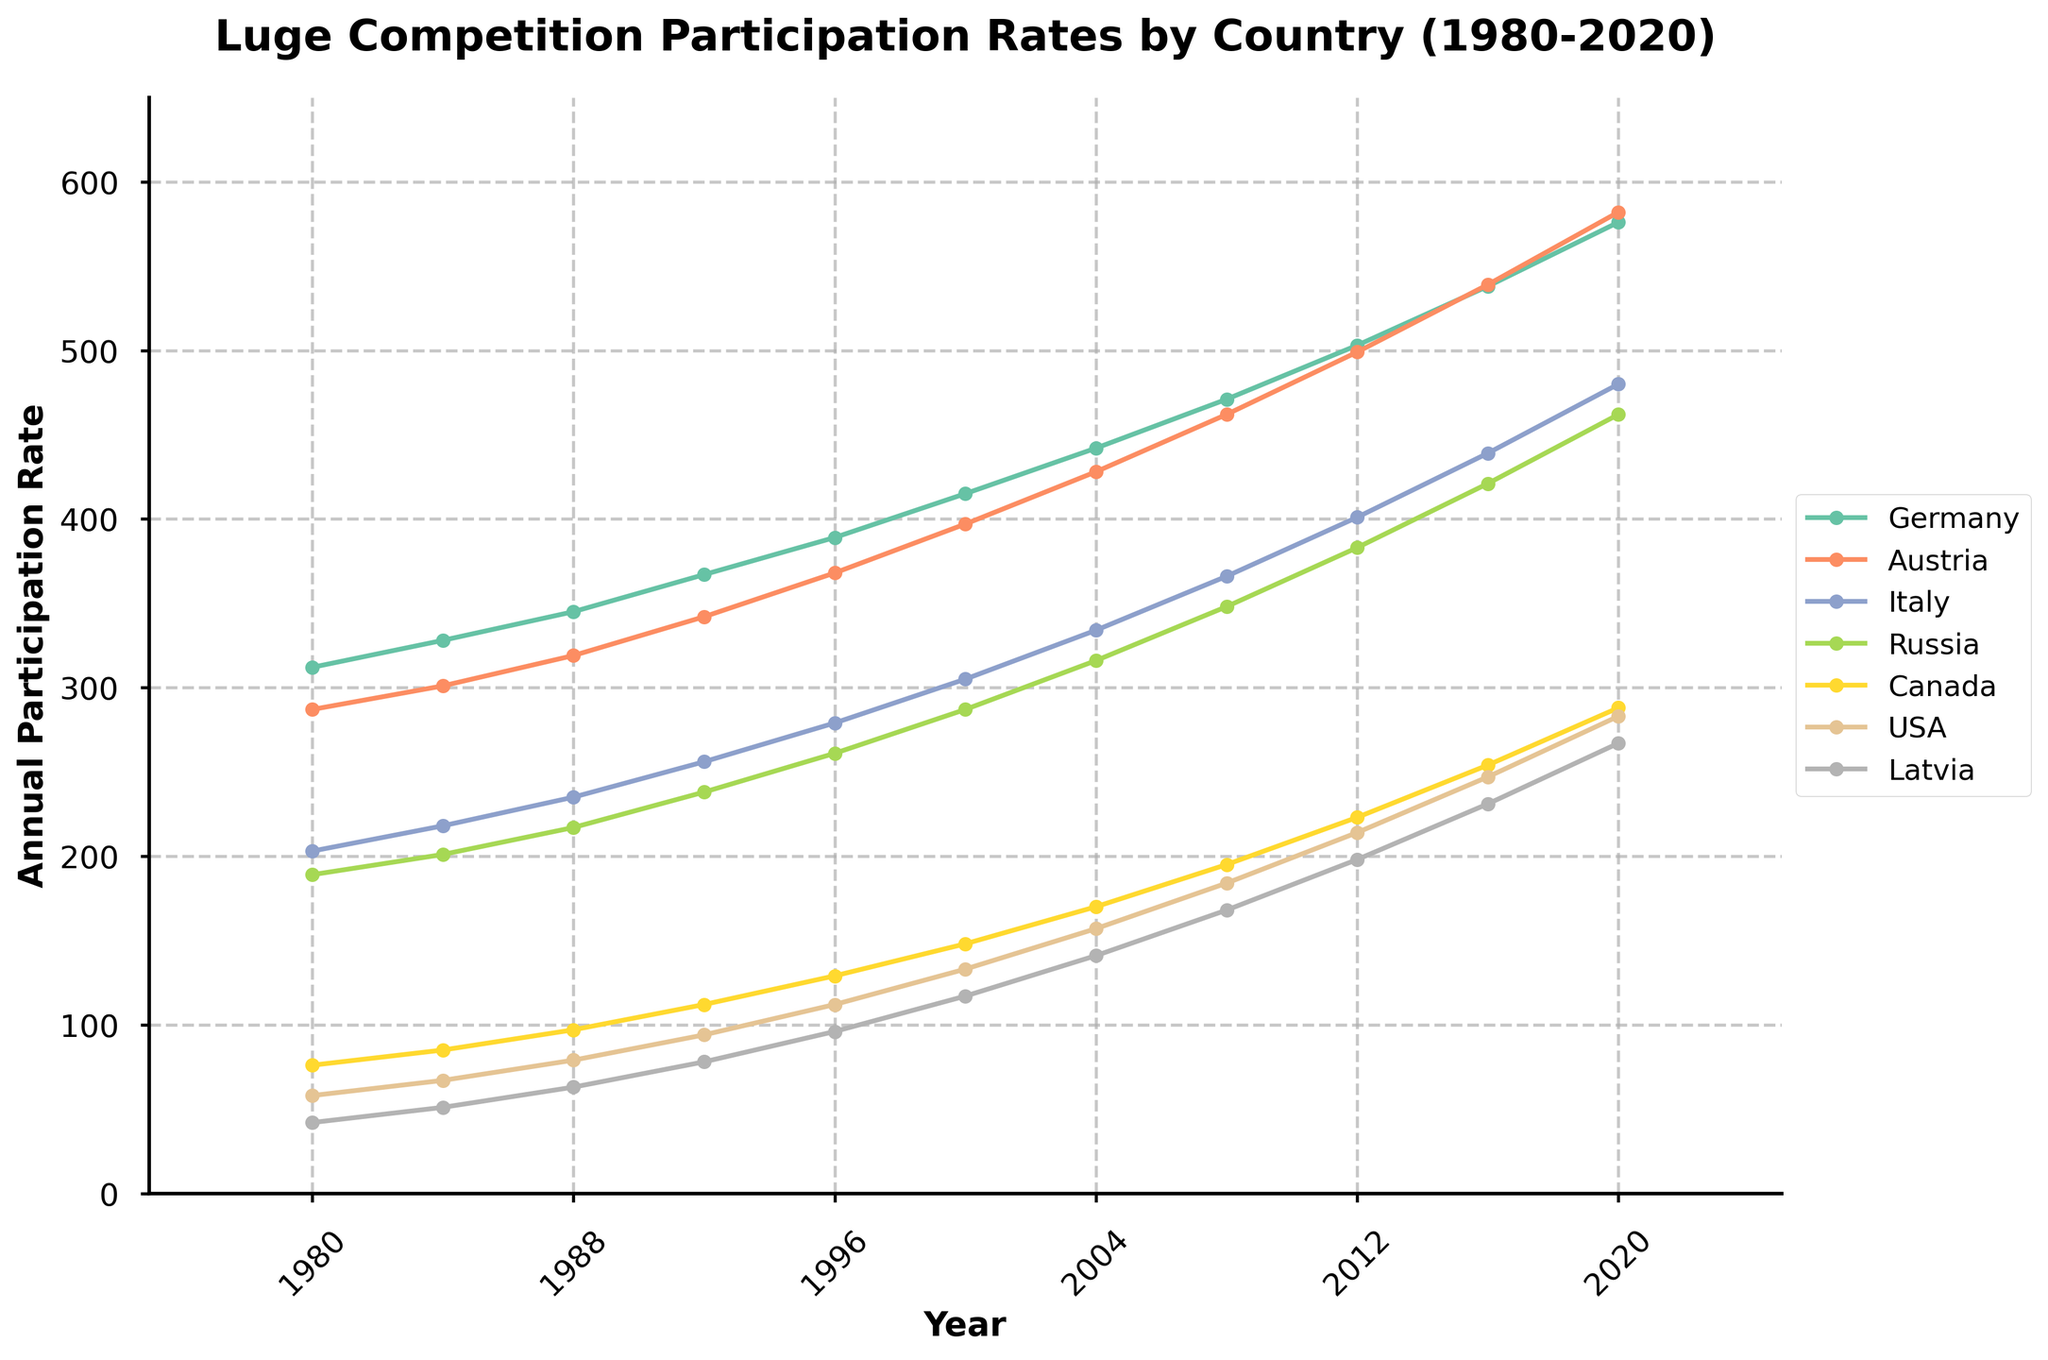What is the general trend in Germany's participation rate from 1980 to 2020? Observing the plot for Germany, there is a consistent upward trend in the annual participation rate from 1980 to 2020. The data points steadily increase over the years.
Answer: Upward trend Which country had the lowest participation rate in 1980? By examining the 1980 markers across all countries, Latvia had the lowest participation rate at 42.
Answer: Latvia Between which years did Austria see the largest increase in annual participation? Observing the plot for Austria, the most significant increase appears between 2016 and 2020 where the line steeply rises. From 2016 to 2020, Austria's participation rate increased from 539 to 582.
Answer: 2016-2020 Who had a higher participation rate in 2000, Canada or Italy? Looking at the lines in the year 2000, Italy had a participation rate of 305 while Canada had 148. Therefore, Italy had a higher rate.
Answer: Italy What is the rate change in the USA’s participation from 1980 to 2020? For the USA, the annual participation rate increased from 58 in 1980 to 283 in 2020. The change is calculated as 283 - 58.
Answer: 225 Which countries show an increasing trend in their participation rates throughout the given years? By looking at the trends from 1980 to 2020, all countries (Germany, Austria, Italy, Russia, Canada, USA, Latvia) show an increasing trend in their participation rates.
Answer: Germany, Austria, Italy, Russia, Canada, USA, Latvia Which country had the lowest overall participation in 2008, and what was the rate? Observing the markers for 2008, Latvia had the lowest participation rate at 168.
Answer: Latvia, 168 What is the combined participation rate of Germany and Russia in 1996? Summing the participation rates of Germany (389) and Russia (261) in 1996 gives 389 + 261.
Answer: 650 How does Germany's participation rate in 2000 compare to Latvia’s in 2008? Germany's rate in 2000 was 415 while Latvia’s in 2008 was 168. Germany's rate was significantly higher.
Answer: Germany's rate is higher Which country had the highest participation rate in 2020? By looking at the endpoints of the lines in 2020, Germany had the highest participation rate at 576.
Answer: Germany 